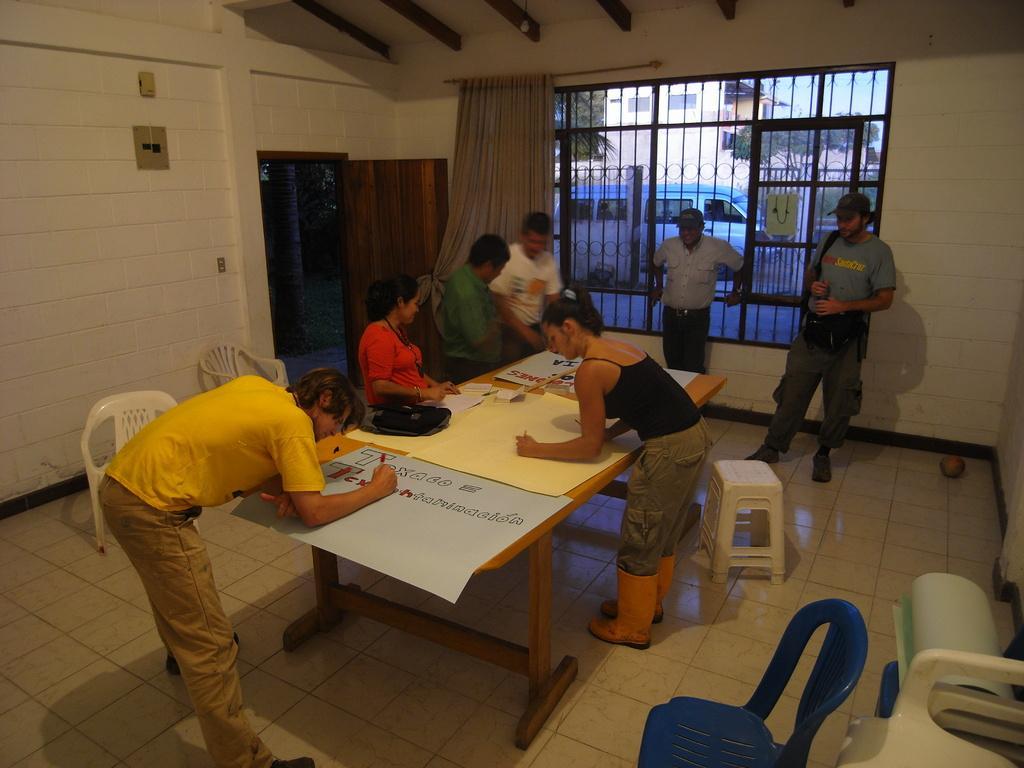Describe this image in one or two sentences. A women writing something on a yellow sheet next to her is a man even he is writing something on blue sheet with a marker. Next to him is another women who is wearing red shirt next to her there are two men discussing something. This is a curtain a door and fencing. Near the fencing a man is standing he is wearing a cap. There are two stools. This is floor 